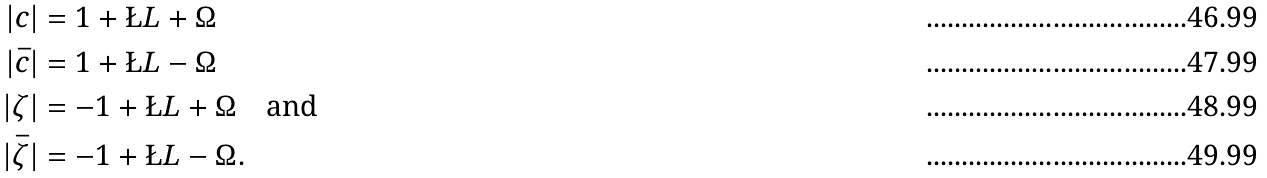<formula> <loc_0><loc_0><loc_500><loc_500>| c | & = 1 + \L L + \Omega \\ | \bar { c } | & = 1 + \L L - \Omega \\ | \zeta | & = - 1 + \L L + \Omega \quad \text {and} \\ | \bar { \zeta } | & = - 1 + \L L - \Omega .</formula> 